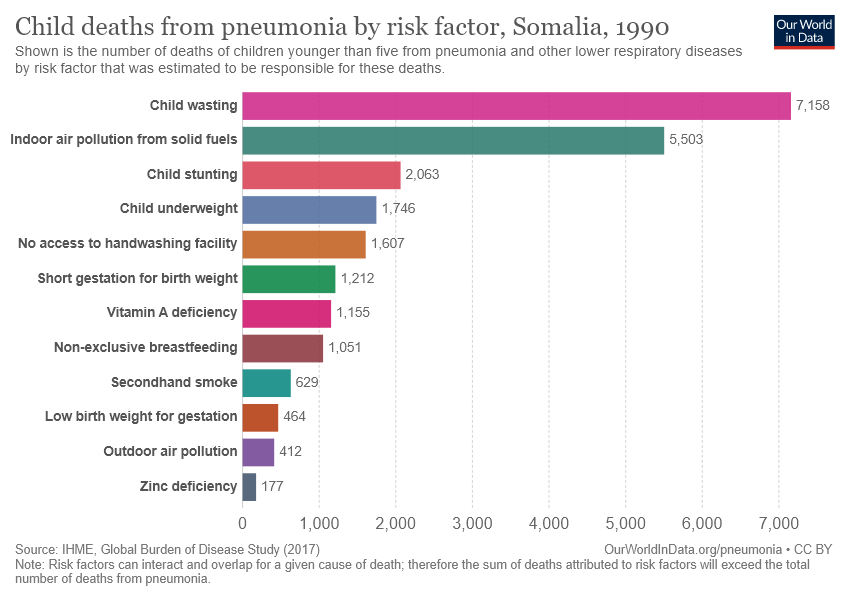Mention a couple of crucial points in this snapshot. The average of the smallest three bars is 351. Child wasting represents the longest bar. 